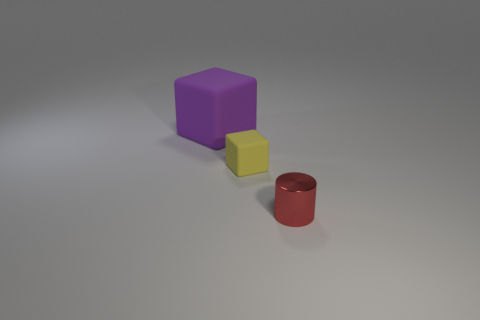Add 3 tiny yellow metallic things. How many objects exist? 6 Subtract all cylinders. How many objects are left? 2 Subtract all blue cylinders. Subtract all red blocks. How many cylinders are left? 1 Subtract all small yellow blocks. Subtract all big matte objects. How many objects are left? 1 Add 1 blocks. How many blocks are left? 3 Add 2 large spheres. How many large spheres exist? 2 Subtract all purple blocks. How many blocks are left? 1 Subtract 0 gray cylinders. How many objects are left? 3 Subtract 1 cylinders. How many cylinders are left? 0 